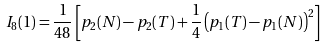<formula> <loc_0><loc_0><loc_500><loc_500>I _ { 8 } ( 1 ) = \frac { 1 } { 4 8 } \left [ p _ { 2 } ( N ) - p _ { 2 } ( T ) + \frac { 1 } { 4 } \left ( p _ { 1 } ( T ) - p _ { 1 } ( N ) \right ) ^ { 2 } \right ]</formula> 